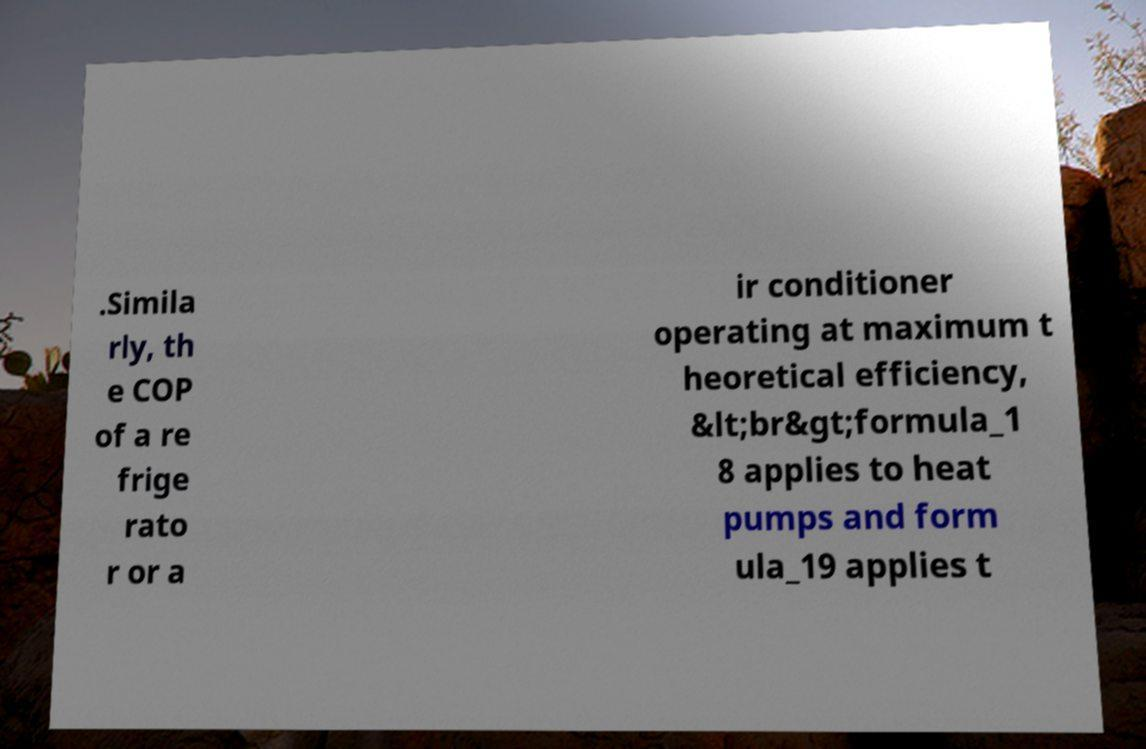Can you accurately transcribe the text from the provided image for me? .Simila rly, th e COP of a re frige rato r or a ir conditioner operating at maximum t heoretical efficiency, &lt;br&gt;formula_1 8 applies to heat pumps and form ula_19 applies t 